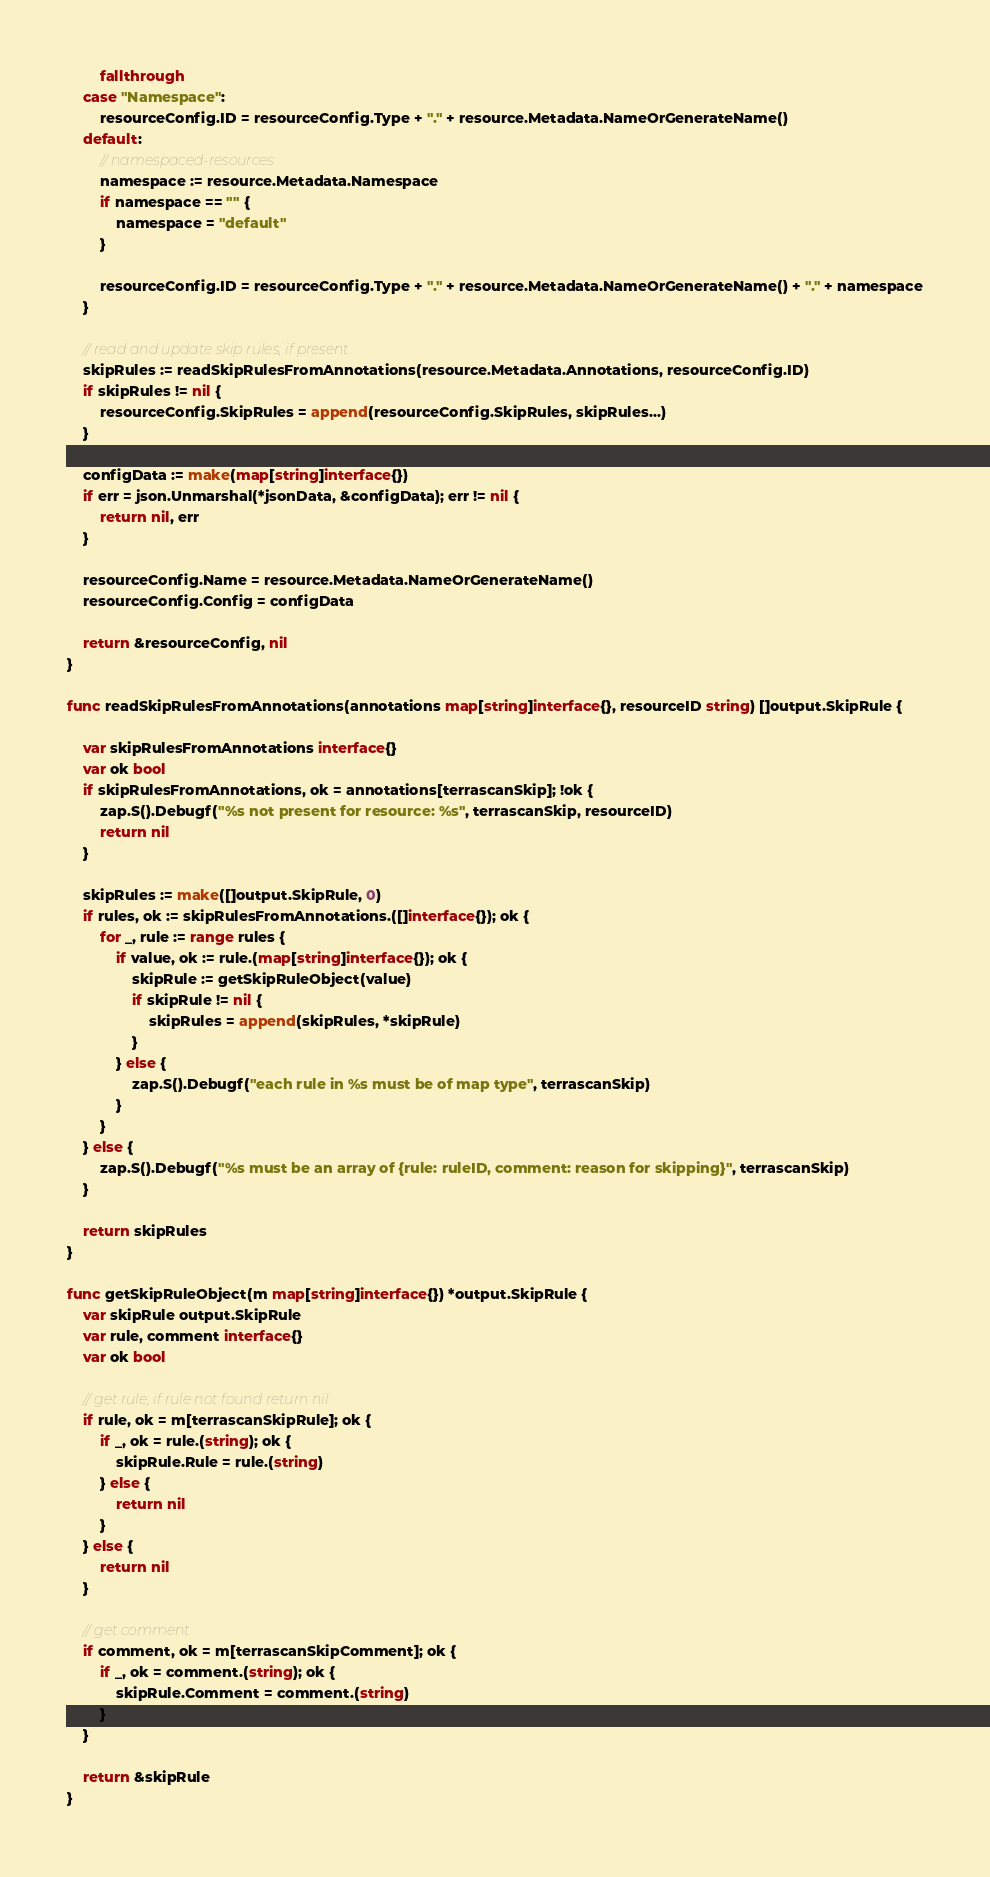<code> <loc_0><loc_0><loc_500><loc_500><_Go_>		fallthrough
	case "Namespace":
		resourceConfig.ID = resourceConfig.Type + "." + resource.Metadata.NameOrGenerateName()
	default:
		// namespaced-resources
		namespace := resource.Metadata.Namespace
		if namespace == "" {
			namespace = "default"
		}

		resourceConfig.ID = resourceConfig.Type + "." + resource.Metadata.NameOrGenerateName() + "." + namespace
	}

	// read and update skip rules, if present
	skipRules := readSkipRulesFromAnnotations(resource.Metadata.Annotations, resourceConfig.ID)
	if skipRules != nil {
		resourceConfig.SkipRules = append(resourceConfig.SkipRules, skipRules...)
	}

	configData := make(map[string]interface{})
	if err = json.Unmarshal(*jsonData, &configData); err != nil {
		return nil, err
	}

	resourceConfig.Name = resource.Metadata.NameOrGenerateName()
	resourceConfig.Config = configData

	return &resourceConfig, nil
}

func readSkipRulesFromAnnotations(annotations map[string]interface{}, resourceID string) []output.SkipRule {

	var skipRulesFromAnnotations interface{}
	var ok bool
	if skipRulesFromAnnotations, ok = annotations[terrascanSkip]; !ok {
		zap.S().Debugf("%s not present for resource: %s", terrascanSkip, resourceID)
		return nil
	}

	skipRules := make([]output.SkipRule, 0)
	if rules, ok := skipRulesFromAnnotations.([]interface{}); ok {
		for _, rule := range rules {
			if value, ok := rule.(map[string]interface{}); ok {
				skipRule := getSkipRuleObject(value)
				if skipRule != nil {
					skipRules = append(skipRules, *skipRule)
				}
			} else {
				zap.S().Debugf("each rule in %s must be of map type", terrascanSkip)
			}
		}
	} else {
		zap.S().Debugf("%s must be an array of {rule: ruleID, comment: reason for skipping}", terrascanSkip)
	}

	return skipRules
}

func getSkipRuleObject(m map[string]interface{}) *output.SkipRule {
	var skipRule output.SkipRule
	var rule, comment interface{}
	var ok bool

	// get rule, if rule not found return nil
	if rule, ok = m[terrascanSkipRule]; ok {
		if _, ok = rule.(string); ok {
			skipRule.Rule = rule.(string)
		} else {
			return nil
		}
	} else {
		return nil
	}

	// get comment
	if comment, ok = m[terrascanSkipComment]; ok {
		if _, ok = comment.(string); ok {
			skipRule.Comment = comment.(string)
		}
	}

	return &skipRule
}
</code> 